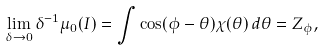<formula> <loc_0><loc_0><loc_500><loc_500>\lim _ { \delta \to 0 } \delta ^ { - 1 } \mu _ { 0 } ( I ) = \int \cos ( \phi - \theta ) \chi ( \theta ) \, d \theta = Z _ { \phi } ,</formula> 